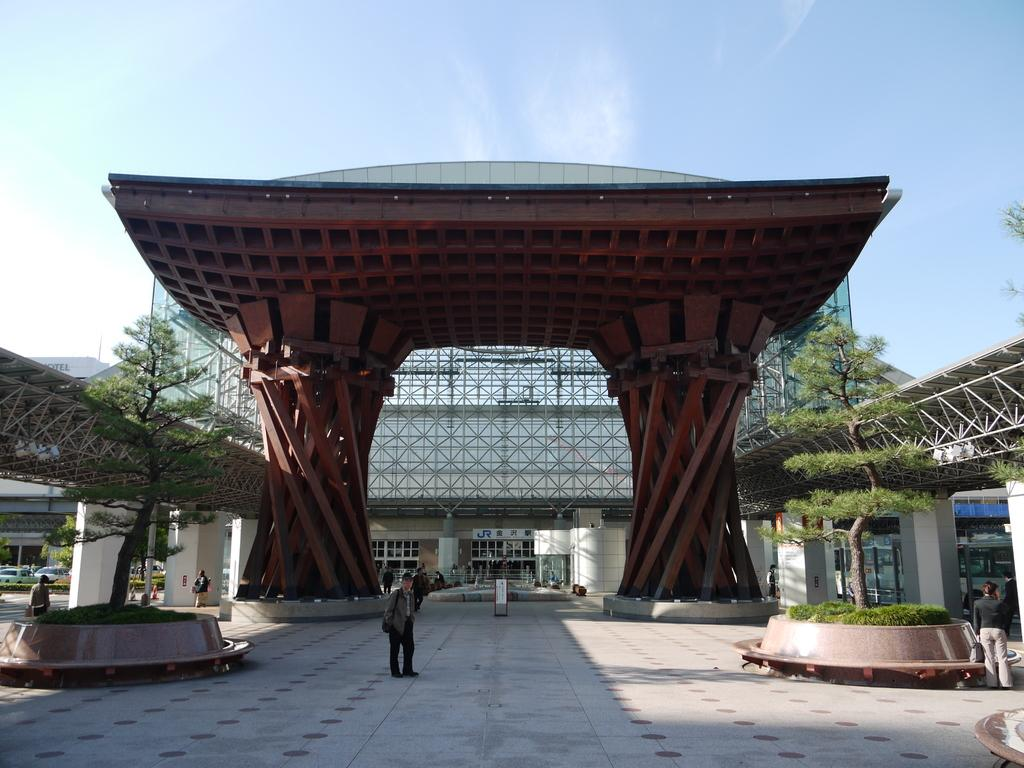Who or what can be seen in the image? There are people in the image. What structures are present in the image? There are buildings in the image. What type of natural elements are visible in the image? There are trees in the image. What other objects can be seen in the image? There are poles in the image. What part of the environment is visible in the image? The sky is visible in the image. How much money is being exchanged between the people in the image? There is no indication of money or any exchange in the image. What type of experience can be gained by observing the people in the image? The image does not provide any information about gaining an experience by observing the people. 